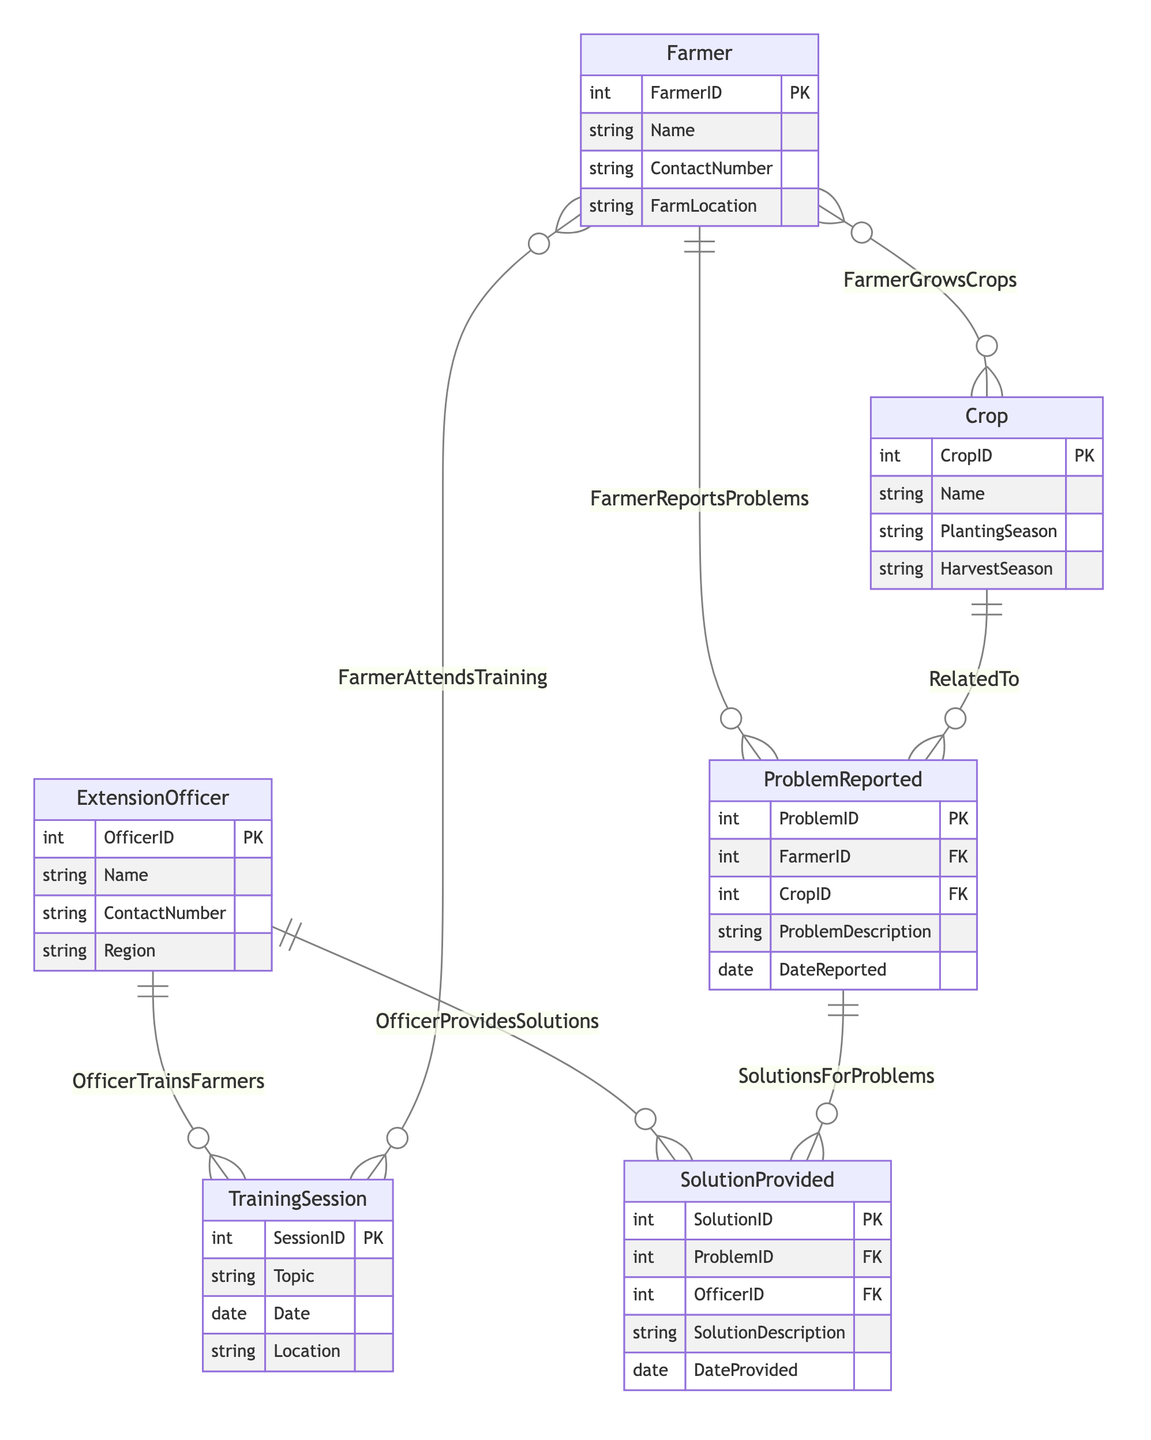What is the primary key of the Extension Officer entity? The primary key is the unique identifier for each record in the entity. In the Extension Officer entity, the primary key is OfficerID, which uniquely identifies each extension officer.
Answer: OfficerID How many attributes does the Crop entity have? To answer this, we look at the Crop entity within the diagram and count the listed attributes: CropID, Name, PlantingSeason, and HarvestSeason, which totals four attributes.
Answer: 4 What is the relationship between Farmer and Training Session? The diagram shows that the relationship between Farmer and Training Session is many to many, indicating that one farmer can attend multiple training sessions and one training session can have multiple farmers attending.
Answer: Many to Many Which entity reports problems? The diagram indicates that the Farmer entity is connected to the Problem Reported entity with a one to many relationship, which means farmers report various problems.
Answer: Farmer What is the foreign key in the Problem Reported entity? The foreign key in the Problem Reported entity refers to external entities that are linked to it. In this entity, the foreign keys are FarmerID and CropID, indicating relationships with the Farmer and Crop entities.
Answer: FarmerID, CropID How many solutions can be provided for each problem reported? The diagram shows a one to many relationship between Problem Reported and Solution Provided, indicating that each problem reported can have multiple solutions provided by extension officers.
Answer: One to Many Which officer provides solutions to problems? The diagram indicates that the Extension Officer entity is linked to the Solution Provided entity with the relationship named Officer Provides Solutions. This means that extension officers offer solutions for problems reported by farmers.
Answer: Extension Officer What does the Training Session entity represent? The Training Session entity represents organized events where farmers can receive training. It includes relevant attributes such as SessionID, Topic, Date, and Location.
Answer: Organized events How are problems reported categorized according to the diagram? Problems reported are categorized in the ProblemReported entity with attributes such as ProblemID, FarmerID, CropID, ProblemDescription, and DateReported, showing the relationships with farmers and crops.
Answer: ProblemReported entity 